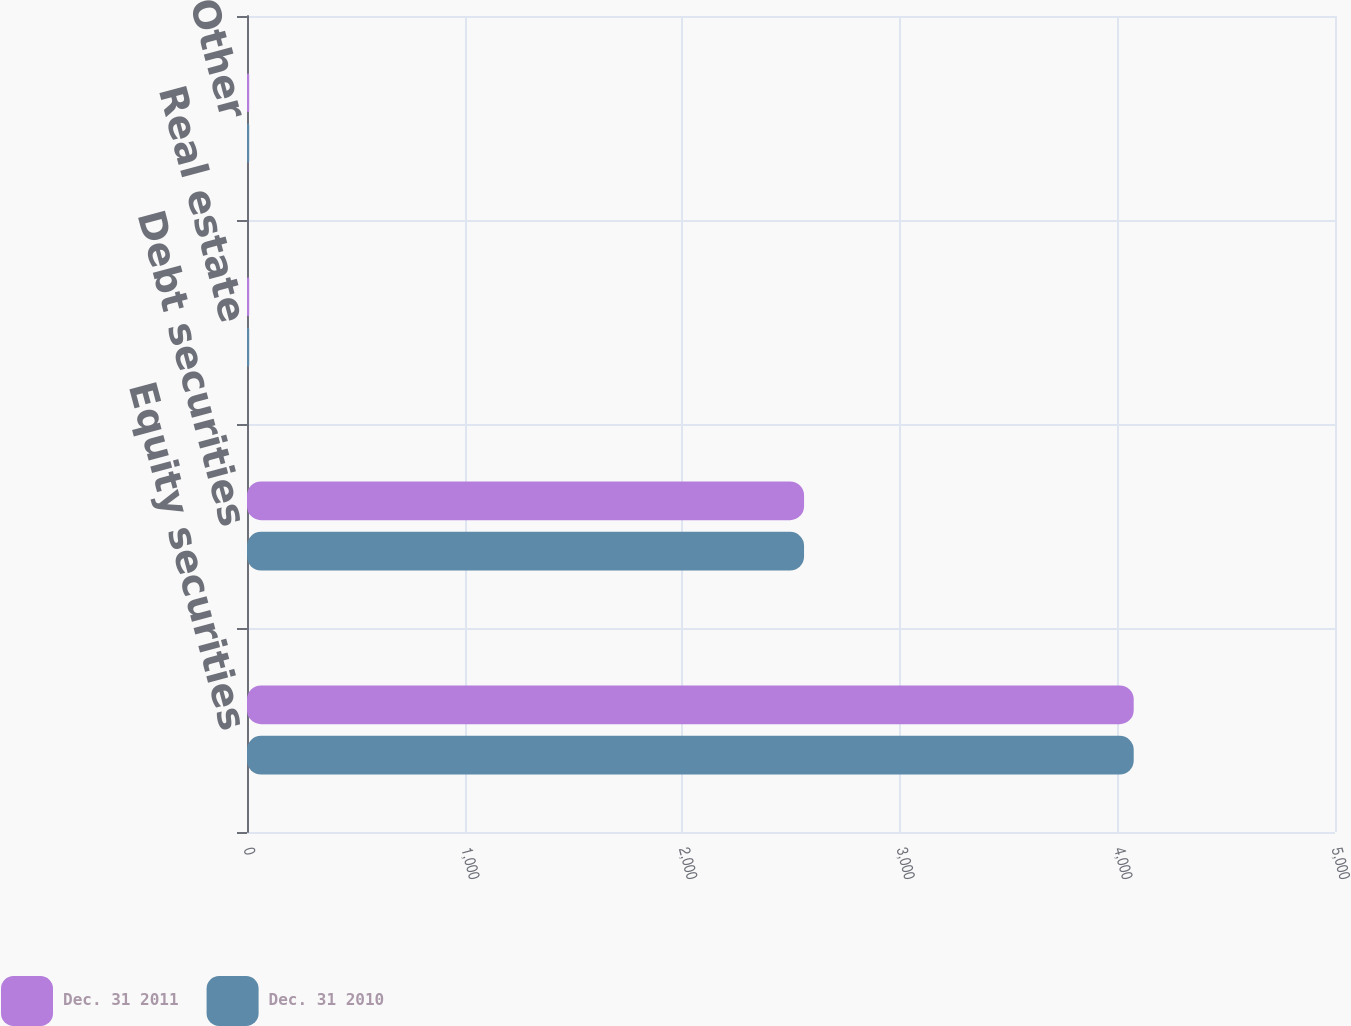Convert chart. <chart><loc_0><loc_0><loc_500><loc_500><stacked_bar_chart><ecel><fcel>Equity securities<fcel>Debt securities<fcel>Real estate<fcel>Other<nl><fcel>Dec. 31 2011<fcel>4075<fcel>2560<fcel>10<fcel>10<nl><fcel>Dec. 31 2010<fcel>4075<fcel>2560<fcel>10<fcel>10<nl></chart> 